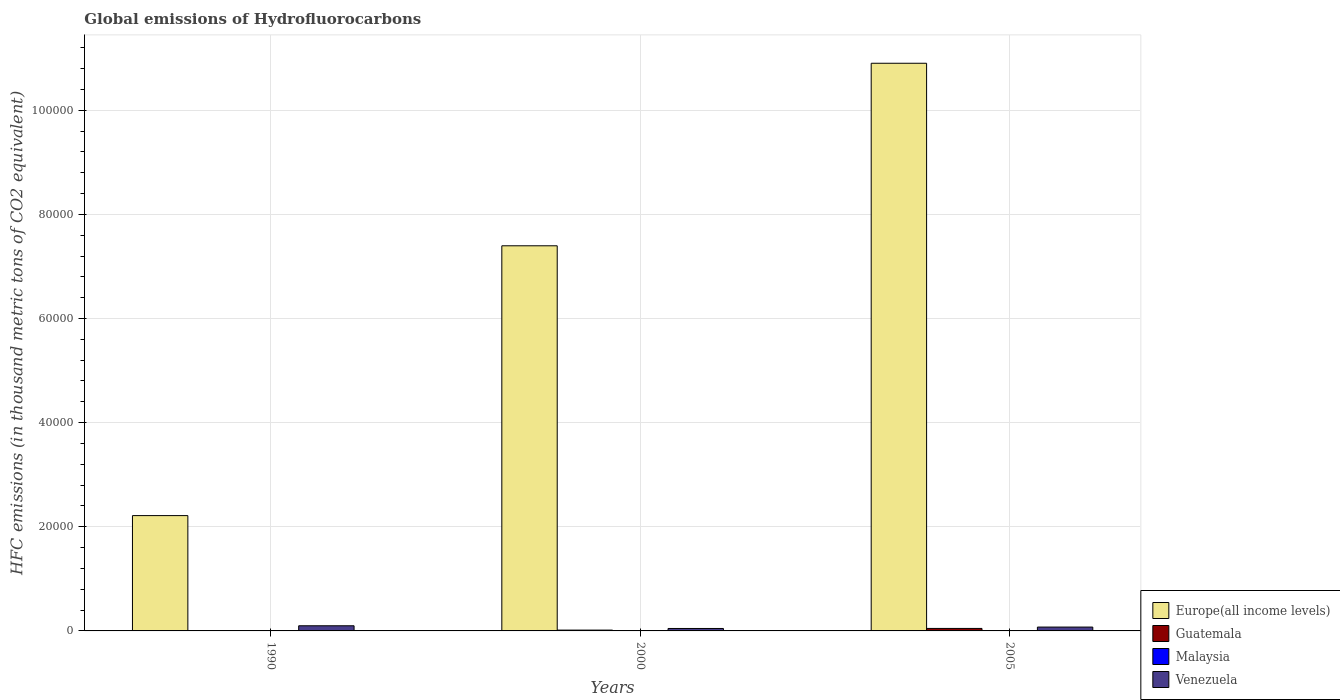How many groups of bars are there?
Give a very brief answer. 3. How many bars are there on the 3rd tick from the left?
Ensure brevity in your answer.  4. What is the label of the 1st group of bars from the left?
Your answer should be very brief. 1990. What is the global emissions of Hydrofluorocarbons in Guatemala in 2005?
Keep it short and to the point. 477.8. Across all years, what is the maximum global emissions of Hydrofluorocarbons in Malaysia?
Provide a short and direct response. 26.1. In which year was the global emissions of Hydrofluorocarbons in Guatemala minimum?
Keep it short and to the point. 1990. What is the total global emissions of Hydrofluorocarbons in Malaysia in the graph?
Ensure brevity in your answer.  33.1. What is the difference between the global emissions of Hydrofluorocarbons in Malaysia in 2000 and that in 2005?
Offer a terse response. -19.2. What is the difference between the global emissions of Hydrofluorocarbons in Venezuela in 2000 and the global emissions of Hydrofluorocarbons in Europe(all income levels) in 1990?
Your response must be concise. -2.17e+04. What is the average global emissions of Hydrofluorocarbons in Malaysia per year?
Provide a short and direct response. 11.03. In the year 2000, what is the difference between the global emissions of Hydrofluorocarbons in Venezuela and global emissions of Hydrofluorocarbons in Malaysia?
Offer a very short reply. 461.6. What is the ratio of the global emissions of Hydrofluorocarbons in Malaysia in 2000 to that in 2005?
Ensure brevity in your answer.  0.26. Is the difference between the global emissions of Hydrofluorocarbons in Venezuela in 2000 and 2005 greater than the difference between the global emissions of Hydrofluorocarbons in Malaysia in 2000 and 2005?
Make the answer very short. No. What is the difference between the highest and the second highest global emissions of Hydrofluorocarbons in Guatemala?
Make the answer very short. 320.2. What is the difference between the highest and the lowest global emissions of Hydrofluorocarbons in Malaysia?
Offer a very short reply. 26. What does the 4th bar from the left in 2000 represents?
Keep it short and to the point. Venezuela. What does the 4th bar from the right in 2005 represents?
Your answer should be very brief. Europe(all income levels). Is it the case that in every year, the sum of the global emissions of Hydrofluorocarbons in Guatemala and global emissions of Hydrofluorocarbons in Venezuela is greater than the global emissions of Hydrofluorocarbons in Malaysia?
Ensure brevity in your answer.  Yes. Are all the bars in the graph horizontal?
Your answer should be compact. No. What is the difference between two consecutive major ticks on the Y-axis?
Offer a very short reply. 2.00e+04. Are the values on the major ticks of Y-axis written in scientific E-notation?
Provide a succinct answer. No. Does the graph contain any zero values?
Ensure brevity in your answer.  No. Where does the legend appear in the graph?
Provide a succinct answer. Bottom right. How are the legend labels stacked?
Provide a succinct answer. Vertical. What is the title of the graph?
Keep it short and to the point. Global emissions of Hydrofluorocarbons. Does "Virgin Islands" appear as one of the legend labels in the graph?
Offer a terse response. No. What is the label or title of the X-axis?
Your answer should be very brief. Years. What is the label or title of the Y-axis?
Your answer should be compact. HFC emissions (in thousand metric tons of CO2 equivalent). What is the HFC emissions (in thousand metric tons of CO2 equivalent) of Europe(all income levels) in 1990?
Your answer should be compact. 2.21e+04. What is the HFC emissions (in thousand metric tons of CO2 equivalent) of Malaysia in 1990?
Make the answer very short. 0.1. What is the HFC emissions (in thousand metric tons of CO2 equivalent) of Venezuela in 1990?
Provide a succinct answer. 989.6. What is the HFC emissions (in thousand metric tons of CO2 equivalent) in Europe(all income levels) in 2000?
Offer a very short reply. 7.40e+04. What is the HFC emissions (in thousand metric tons of CO2 equivalent) in Guatemala in 2000?
Provide a short and direct response. 157.6. What is the HFC emissions (in thousand metric tons of CO2 equivalent) in Malaysia in 2000?
Your answer should be compact. 6.9. What is the HFC emissions (in thousand metric tons of CO2 equivalent) in Venezuela in 2000?
Give a very brief answer. 468.5. What is the HFC emissions (in thousand metric tons of CO2 equivalent) of Europe(all income levels) in 2005?
Give a very brief answer. 1.09e+05. What is the HFC emissions (in thousand metric tons of CO2 equivalent) of Guatemala in 2005?
Make the answer very short. 477.8. What is the HFC emissions (in thousand metric tons of CO2 equivalent) of Malaysia in 2005?
Your answer should be very brief. 26.1. What is the HFC emissions (in thousand metric tons of CO2 equivalent) of Venezuela in 2005?
Ensure brevity in your answer.  738.4. Across all years, what is the maximum HFC emissions (in thousand metric tons of CO2 equivalent) of Europe(all income levels)?
Your answer should be very brief. 1.09e+05. Across all years, what is the maximum HFC emissions (in thousand metric tons of CO2 equivalent) in Guatemala?
Give a very brief answer. 477.8. Across all years, what is the maximum HFC emissions (in thousand metric tons of CO2 equivalent) in Malaysia?
Your answer should be very brief. 26.1. Across all years, what is the maximum HFC emissions (in thousand metric tons of CO2 equivalent) in Venezuela?
Provide a succinct answer. 989.6. Across all years, what is the minimum HFC emissions (in thousand metric tons of CO2 equivalent) of Europe(all income levels)?
Your answer should be very brief. 2.21e+04. Across all years, what is the minimum HFC emissions (in thousand metric tons of CO2 equivalent) of Malaysia?
Your response must be concise. 0.1. Across all years, what is the minimum HFC emissions (in thousand metric tons of CO2 equivalent) in Venezuela?
Your response must be concise. 468.5. What is the total HFC emissions (in thousand metric tons of CO2 equivalent) in Europe(all income levels) in the graph?
Offer a terse response. 2.05e+05. What is the total HFC emissions (in thousand metric tons of CO2 equivalent) of Guatemala in the graph?
Keep it short and to the point. 635.5. What is the total HFC emissions (in thousand metric tons of CO2 equivalent) of Malaysia in the graph?
Ensure brevity in your answer.  33.1. What is the total HFC emissions (in thousand metric tons of CO2 equivalent) of Venezuela in the graph?
Offer a very short reply. 2196.5. What is the difference between the HFC emissions (in thousand metric tons of CO2 equivalent) of Europe(all income levels) in 1990 and that in 2000?
Give a very brief answer. -5.18e+04. What is the difference between the HFC emissions (in thousand metric tons of CO2 equivalent) of Guatemala in 1990 and that in 2000?
Offer a terse response. -157.5. What is the difference between the HFC emissions (in thousand metric tons of CO2 equivalent) in Venezuela in 1990 and that in 2000?
Ensure brevity in your answer.  521.1. What is the difference between the HFC emissions (in thousand metric tons of CO2 equivalent) of Europe(all income levels) in 1990 and that in 2005?
Offer a terse response. -8.69e+04. What is the difference between the HFC emissions (in thousand metric tons of CO2 equivalent) of Guatemala in 1990 and that in 2005?
Offer a very short reply. -477.7. What is the difference between the HFC emissions (in thousand metric tons of CO2 equivalent) of Venezuela in 1990 and that in 2005?
Give a very brief answer. 251.2. What is the difference between the HFC emissions (in thousand metric tons of CO2 equivalent) in Europe(all income levels) in 2000 and that in 2005?
Keep it short and to the point. -3.51e+04. What is the difference between the HFC emissions (in thousand metric tons of CO2 equivalent) of Guatemala in 2000 and that in 2005?
Keep it short and to the point. -320.2. What is the difference between the HFC emissions (in thousand metric tons of CO2 equivalent) in Malaysia in 2000 and that in 2005?
Provide a succinct answer. -19.2. What is the difference between the HFC emissions (in thousand metric tons of CO2 equivalent) in Venezuela in 2000 and that in 2005?
Your answer should be compact. -269.9. What is the difference between the HFC emissions (in thousand metric tons of CO2 equivalent) in Europe(all income levels) in 1990 and the HFC emissions (in thousand metric tons of CO2 equivalent) in Guatemala in 2000?
Keep it short and to the point. 2.20e+04. What is the difference between the HFC emissions (in thousand metric tons of CO2 equivalent) in Europe(all income levels) in 1990 and the HFC emissions (in thousand metric tons of CO2 equivalent) in Malaysia in 2000?
Ensure brevity in your answer.  2.21e+04. What is the difference between the HFC emissions (in thousand metric tons of CO2 equivalent) in Europe(all income levels) in 1990 and the HFC emissions (in thousand metric tons of CO2 equivalent) in Venezuela in 2000?
Your answer should be very brief. 2.17e+04. What is the difference between the HFC emissions (in thousand metric tons of CO2 equivalent) in Guatemala in 1990 and the HFC emissions (in thousand metric tons of CO2 equivalent) in Malaysia in 2000?
Ensure brevity in your answer.  -6.8. What is the difference between the HFC emissions (in thousand metric tons of CO2 equivalent) in Guatemala in 1990 and the HFC emissions (in thousand metric tons of CO2 equivalent) in Venezuela in 2000?
Offer a terse response. -468.4. What is the difference between the HFC emissions (in thousand metric tons of CO2 equivalent) of Malaysia in 1990 and the HFC emissions (in thousand metric tons of CO2 equivalent) of Venezuela in 2000?
Give a very brief answer. -468.4. What is the difference between the HFC emissions (in thousand metric tons of CO2 equivalent) in Europe(all income levels) in 1990 and the HFC emissions (in thousand metric tons of CO2 equivalent) in Guatemala in 2005?
Make the answer very short. 2.17e+04. What is the difference between the HFC emissions (in thousand metric tons of CO2 equivalent) of Europe(all income levels) in 1990 and the HFC emissions (in thousand metric tons of CO2 equivalent) of Malaysia in 2005?
Give a very brief answer. 2.21e+04. What is the difference between the HFC emissions (in thousand metric tons of CO2 equivalent) in Europe(all income levels) in 1990 and the HFC emissions (in thousand metric tons of CO2 equivalent) in Venezuela in 2005?
Make the answer very short. 2.14e+04. What is the difference between the HFC emissions (in thousand metric tons of CO2 equivalent) in Guatemala in 1990 and the HFC emissions (in thousand metric tons of CO2 equivalent) in Venezuela in 2005?
Your answer should be compact. -738.3. What is the difference between the HFC emissions (in thousand metric tons of CO2 equivalent) of Malaysia in 1990 and the HFC emissions (in thousand metric tons of CO2 equivalent) of Venezuela in 2005?
Provide a short and direct response. -738.3. What is the difference between the HFC emissions (in thousand metric tons of CO2 equivalent) in Europe(all income levels) in 2000 and the HFC emissions (in thousand metric tons of CO2 equivalent) in Guatemala in 2005?
Offer a terse response. 7.35e+04. What is the difference between the HFC emissions (in thousand metric tons of CO2 equivalent) in Europe(all income levels) in 2000 and the HFC emissions (in thousand metric tons of CO2 equivalent) in Malaysia in 2005?
Your answer should be compact. 7.39e+04. What is the difference between the HFC emissions (in thousand metric tons of CO2 equivalent) of Europe(all income levels) in 2000 and the HFC emissions (in thousand metric tons of CO2 equivalent) of Venezuela in 2005?
Keep it short and to the point. 7.32e+04. What is the difference between the HFC emissions (in thousand metric tons of CO2 equivalent) of Guatemala in 2000 and the HFC emissions (in thousand metric tons of CO2 equivalent) of Malaysia in 2005?
Keep it short and to the point. 131.5. What is the difference between the HFC emissions (in thousand metric tons of CO2 equivalent) of Guatemala in 2000 and the HFC emissions (in thousand metric tons of CO2 equivalent) of Venezuela in 2005?
Your answer should be compact. -580.8. What is the difference between the HFC emissions (in thousand metric tons of CO2 equivalent) of Malaysia in 2000 and the HFC emissions (in thousand metric tons of CO2 equivalent) of Venezuela in 2005?
Ensure brevity in your answer.  -731.5. What is the average HFC emissions (in thousand metric tons of CO2 equivalent) of Europe(all income levels) per year?
Keep it short and to the point. 6.84e+04. What is the average HFC emissions (in thousand metric tons of CO2 equivalent) of Guatemala per year?
Ensure brevity in your answer.  211.83. What is the average HFC emissions (in thousand metric tons of CO2 equivalent) of Malaysia per year?
Keep it short and to the point. 11.03. What is the average HFC emissions (in thousand metric tons of CO2 equivalent) in Venezuela per year?
Give a very brief answer. 732.17. In the year 1990, what is the difference between the HFC emissions (in thousand metric tons of CO2 equivalent) in Europe(all income levels) and HFC emissions (in thousand metric tons of CO2 equivalent) in Guatemala?
Offer a terse response. 2.21e+04. In the year 1990, what is the difference between the HFC emissions (in thousand metric tons of CO2 equivalent) of Europe(all income levels) and HFC emissions (in thousand metric tons of CO2 equivalent) of Malaysia?
Your answer should be compact. 2.21e+04. In the year 1990, what is the difference between the HFC emissions (in thousand metric tons of CO2 equivalent) of Europe(all income levels) and HFC emissions (in thousand metric tons of CO2 equivalent) of Venezuela?
Offer a very short reply. 2.12e+04. In the year 1990, what is the difference between the HFC emissions (in thousand metric tons of CO2 equivalent) of Guatemala and HFC emissions (in thousand metric tons of CO2 equivalent) of Malaysia?
Ensure brevity in your answer.  0. In the year 1990, what is the difference between the HFC emissions (in thousand metric tons of CO2 equivalent) in Guatemala and HFC emissions (in thousand metric tons of CO2 equivalent) in Venezuela?
Give a very brief answer. -989.5. In the year 1990, what is the difference between the HFC emissions (in thousand metric tons of CO2 equivalent) in Malaysia and HFC emissions (in thousand metric tons of CO2 equivalent) in Venezuela?
Provide a short and direct response. -989.5. In the year 2000, what is the difference between the HFC emissions (in thousand metric tons of CO2 equivalent) of Europe(all income levels) and HFC emissions (in thousand metric tons of CO2 equivalent) of Guatemala?
Offer a terse response. 7.38e+04. In the year 2000, what is the difference between the HFC emissions (in thousand metric tons of CO2 equivalent) in Europe(all income levels) and HFC emissions (in thousand metric tons of CO2 equivalent) in Malaysia?
Ensure brevity in your answer.  7.40e+04. In the year 2000, what is the difference between the HFC emissions (in thousand metric tons of CO2 equivalent) of Europe(all income levels) and HFC emissions (in thousand metric tons of CO2 equivalent) of Venezuela?
Your answer should be very brief. 7.35e+04. In the year 2000, what is the difference between the HFC emissions (in thousand metric tons of CO2 equivalent) of Guatemala and HFC emissions (in thousand metric tons of CO2 equivalent) of Malaysia?
Ensure brevity in your answer.  150.7. In the year 2000, what is the difference between the HFC emissions (in thousand metric tons of CO2 equivalent) of Guatemala and HFC emissions (in thousand metric tons of CO2 equivalent) of Venezuela?
Make the answer very short. -310.9. In the year 2000, what is the difference between the HFC emissions (in thousand metric tons of CO2 equivalent) of Malaysia and HFC emissions (in thousand metric tons of CO2 equivalent) of Venezuela?
Your answer should be compact. -461.6. In the year 2005, what is the difference between the HFC emissions (in thousand metric tons of CO2 equivalent) in Europe(all income levels) and HFC emissions (in thousand metric tons of CO2 equivalent) in Guatemala?
Provide a succinct answer. 1.09e+05. In the year 2005, what is the difference between the HFC emissions (in thousand metric tons of CO2 equivalent) in Europe(all income levels) and HFC emissions (in thousand metric tons of CO2 equivalent) in Malaysia?
Your answer should be very brief. 1.09e+05. In the year 2005, what is the difference between the HFC emissions (in thousand metric tons of CO2 equivalent) of Europe(all income levels) and HFC emissions (in thousand metric tons of CO2 equivalent) of Venezuela?
Your answer should be compact. 1.08e+05. In the year 2005, what is the difference between the HFC emissions (in thousand metric tons of CO2 equivalent) of Guatemala and HFC emissions (in thousand metric tons of CO2 equivalent) of Malaysia?
Your answer should be very brief. 451.7. In the year 2005, what is the difference between the HFC emissions (in thousand metric tons of CO2 equivalent) in Guatemala and HFC emissions (in thousand metric tons of CO2 equivalent) in Venezuela?
Your response must be concise. -260.6. In the year 2005, what is the difference between the HFC emissions (in thousand metric tons of CO2 equivalent) in Malaysia and HFC emissions (in thousand metric tons of CO2 equivalent) in Venezuela?
Your response must be concise. -712.3. What is the ratio of the HFC emissions (in thousand metric tons of CO2 equivalent) of Europe(all income levels) in 1990 to that in 2000?
Offer a terse response. 0.3. What is the ratio of the HFC emissions (in thousand metric tons of CO2 equivalent) in Guatemala in 1990 to that in 2000?
Keep it short and to the point. 0. What is the ratio of the HFC emissions (in thousand metric tons of CO2 equivalent) in Malaysia in 1990 to that in 2000?
Offer a terse response. 0.01. What is the ratio of the HFC emissions (in thousand metric tons of CO2 equivalent) in Venezuela in 1990 to that in 2000?
Make the answer very short. 2.11. What is the ratio of the HFC emissions (in thousand metric tons of CO2 equivalent) in Europe(all income levels) in 1990 to that in 2005?
Give a very brief answer. 0.2. What is the ratio of the HFC emissions (in thousand metric tons of CO2 equivalent) in Guatemala in 1990 to that in 2005?
Ensure brevity in your answer.  0. What is the ratio of the HFC emissions (in thousand metric tons of CO2 equivalent) of Malaysia in 1990 to that in 2005?
Offer a terse response. 0. What is the ratio of the HFC emissions (in thousand metric tons of CO2 equivalent) in Venezuela in 1990 to that in 2005?
Ensure brevity in your answer.  1.34. What is the ratio of the HFC emissions (in thousand metric tons of CO2 equivalent) in Europe(all income levels) in 2000 to that in 2005?
Make the answer very short. 0.68. What is the ratio of the HFC emissions (in thousand metric tons of CO2 equivalent) of Guatemala in 2000 to that in 2005?
Offer a very short reply. 0.33. What is the ratio of the HFC emissions (in thousand metric tons of CO2 equivalent) in Malaysia in 2000 to that in 2005?
Your response must be concise. 0.26. What is the ratio of the HFC emissions (in thousand metric tons of CO2 equivalent) in Venezuela in 2000 to that in 2005?
Your response must be concise. 0.63. What is the difference between the highest and the second highest HFC emissions (in thousand metric tons of CO2 equivalent) in Europe(all income levels)?
Offer a terse response. 3.51e+04. What is the difference between the highest and the second highest HFC emissions (in thousand metric tons of CO2 equivalent) of Guatemala?
Offer a very short reply. 320.2. What is the difference between the highest and the second highest HFC emissions (in thousand metric tons of CO2 equivalent) in Malaysia?
Offer a very short reply. 19.2. What is the difference between the highest and the second highest HFC emissions (in thousand metric tons of CO2 equivalent) in Venezuela?
Make the answer very short. 251.2. What is the difference between the highest and the lowest HFC emissions (in thousand metric tons of CO2 equivalent) of Europe(all income levels)?
Your answer should be very brief. 8.69e+04. What is the difference between the highest and the lowest HFC emissions (in thousand metric tons of CO2 equivalent) in Guatemala?
Offer a very short reply. 477.7. What is the difference between the highest and the lowest HFC emissions (in thousand metric tons of CO2 equivalent) in Venezuela?
Keep it short and to the point. 521.1. 